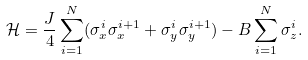Convert formula to latex. <formula><loc_0><loc_0><loc_500><loc_500>\mathcal { H } = \frac { J } { 4 } \sum _ { i = 1 } ^ { N } ( \sigma ^ { i } _ { x } \sigma ^ { i + 1 } _ { x } + \sigma ^ { i } _ { y } \sigma ^ { i + 1 } _ { y } ) - B \sum _ { i = 1 } ^ { N } \sigma _ { z } ^ { i } .</formula> 